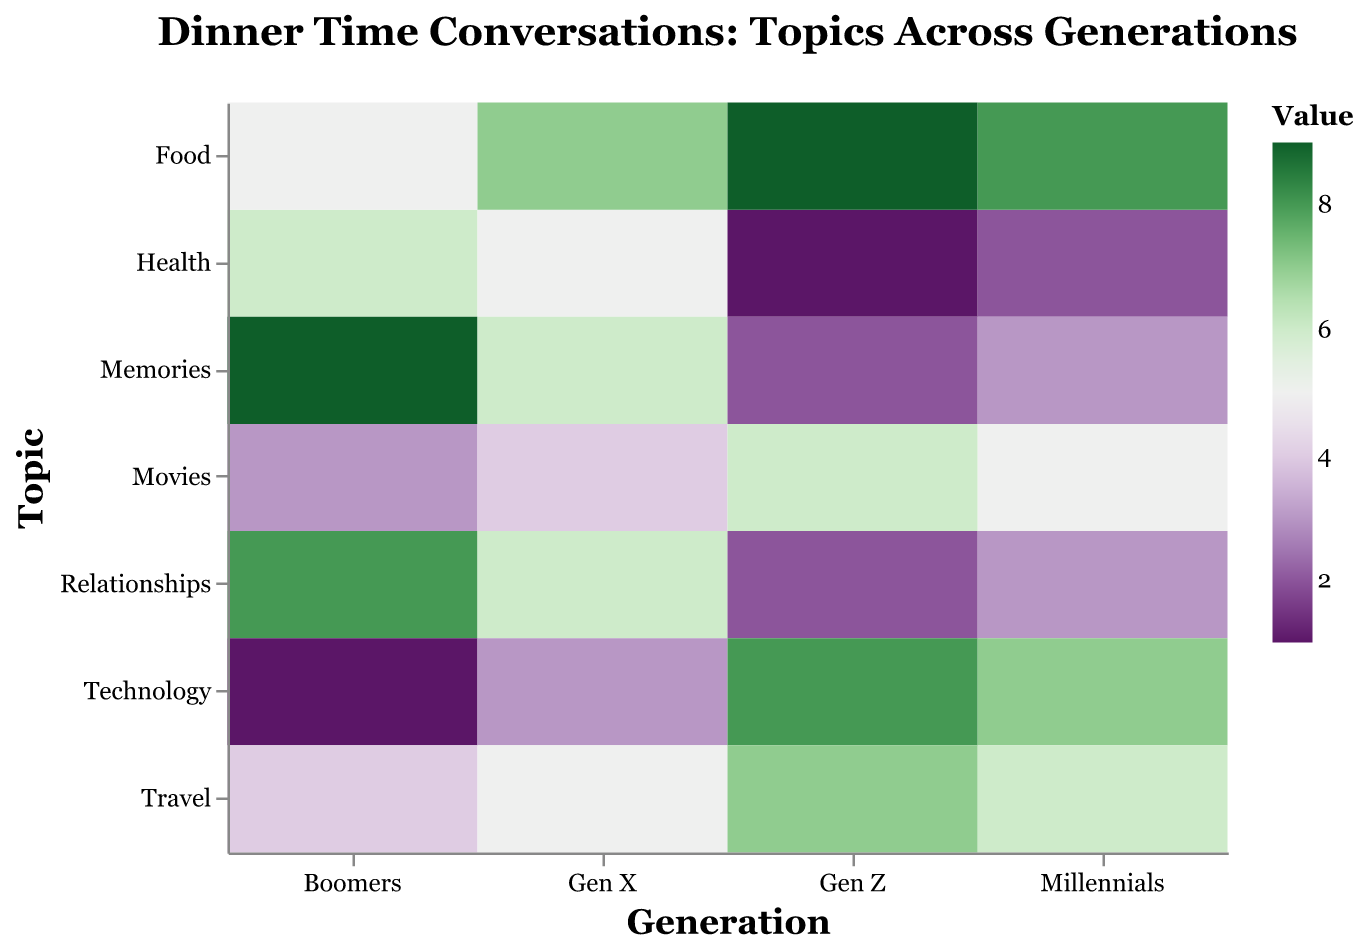What is the most discussed topic for Boomers? By examining the color intensity corresponding to Boomers across different topics, the darkest cell indicates the most discussed topic, which is "Memories" with a value of 9.
Answer: Memories Which generation discusses Technology the most? The cell with the highest value in the Technology row indicates the generation that discusses Technology the most. "Gen Z" has the darkest cell with a value of 8.
Answer: Gen Z Which topic has equal discussion frequency between Gen X and Millennials? By visually comparing the colors in the cells for Gen X and Millennials across topics, we see that the "Movies" and "Travel" topics have similar intensities. Both have a value of 4 for Gen X and 5 for Millennials in the Movies topic.
Answer: Movies and Travel What is the least discussed topic for Millennials? The cell with the lightest color for Millennials indicates the least discussed topic, which is "Health" with a value of 2.
Answer: Health Out of Food and Health, which topic is more popular among Gen Z? By comparing the color intensity in the Gen Z column for Food and Health, the cell for Food is darker with a value of 9, compared to Health which is 1.
Answer: Food How many topics do Boomers have a discussion frequency higher than 5? By checking each topic for Boomers and counting those with a value greater than 5: Relationships (8), Health (6), Memories (9), and Food (5 but not greater), we get three topics.
Answer: 3 What is the average discussion frequency of Technology across all generations? Sum the values of the Technology row: Boomers (1), Gen X (3), Millennials (7), Gen Z (8), resulting in the total of 19. There are four generations, so divide the total by 4: 19/4 = 4.75.
Answer: 4.75 Which generation has the most diversified interest in topics discussed (based on the range of values)? Calculate the range for each generation by subtracting the smallest value from the largest. Boomers (9-1=8), Gen X (7-3=4), Millennials (8-2=6), Gen Z (9-1=8). Boomers and Gen Z both have the largest range of 8.
Answer: Boomers and Gen Z Which topic shows the least variation in discussion frequency across generations? By comparing the color variance in each row, "Movies" have values ranging from 3 to 6, "Travel" from 4 to 7. "Movies" have the least variation (difference of 3).
Answer: Movies If we consider Relationships and Food as key emotional topics, which generation discusses these the most combined? Sum the values for Relationships and Food for each generation: Boomers (8+5=13), Gen X (6+7=13), Millennials (3+8=11), Gen Z (2+9=11). Boomers and Gen X both discuss these the most with a sum of 13.
Answer: Boomers and Gen X 